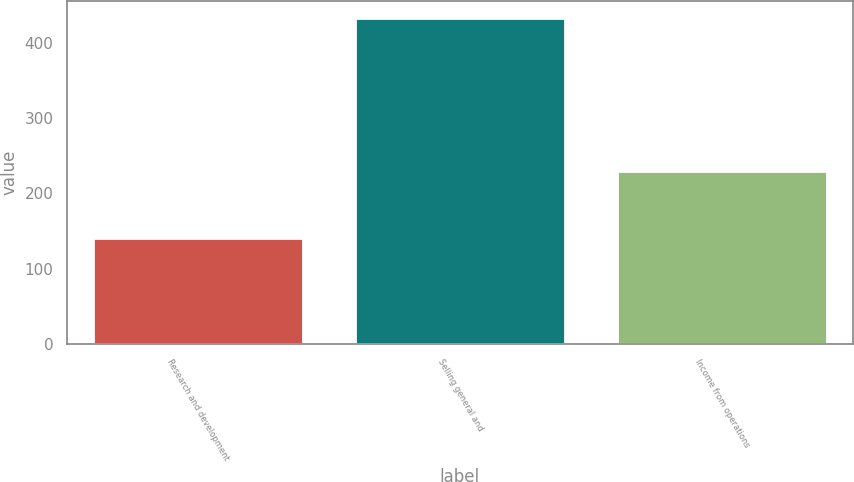<chart> <loc_0><loc_0><loc_500><loc_500><bar_chart><fcel>Research and development<fcel>Selling general and<fcel>Income from operations<nl><fcel>141<fcel>433<fcel>230<nl></chart> 